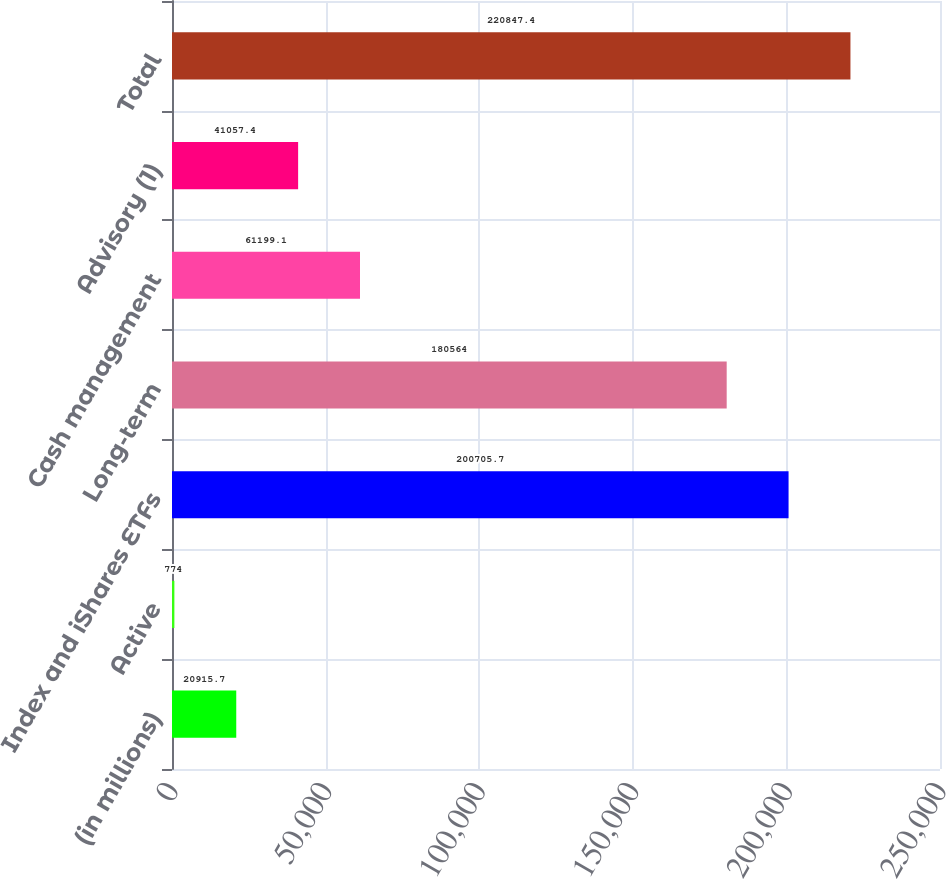<chart> <loc_0><loc_0><loc_500><loc_500><bar_chart><fcel>(in millions)<fcel>Active<fcel>Index and iShares ETFs<fcel>Long-term<fcel>Cash management<fcel>Advisory (1)<fcel>Total<nl><fcel>20915.7<fcel>774<fcel>200706<fcel>180564<fcel>61199.1<fcel>41057.4<fcel>220847<nl></chart> 